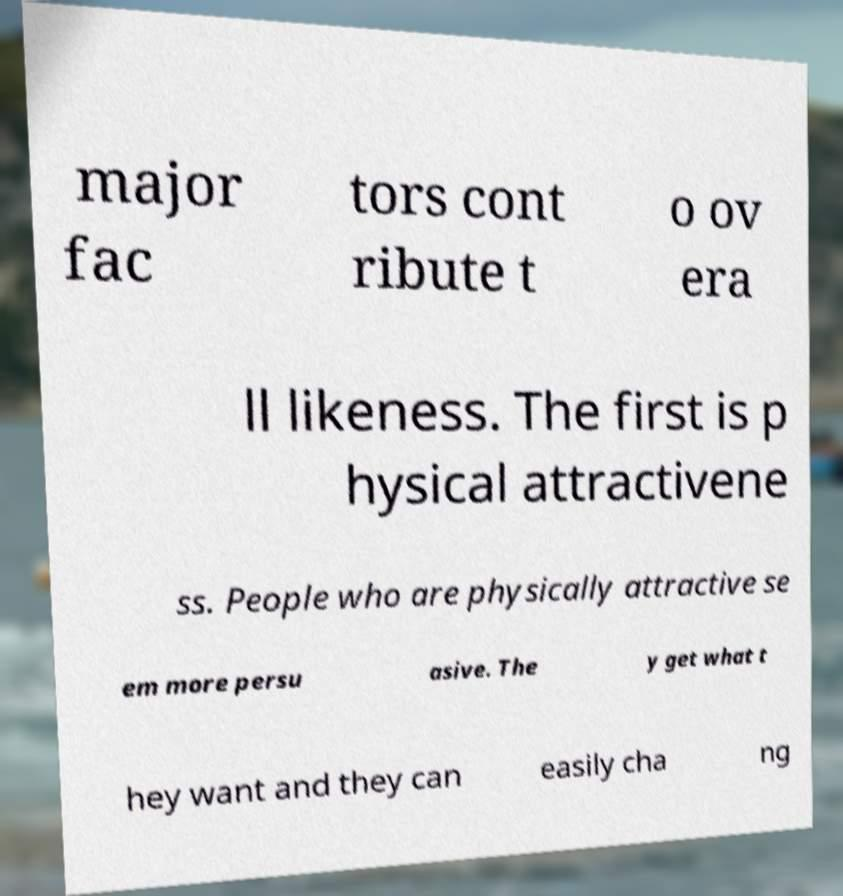Could you extract and type out the text from this image? major fac tors cont ribute t o ov era ll likeness. The first is p hysical attractivene ss. People who are physically attractive se em more persu asive. The y get what t hey want and they can easily cha ng 